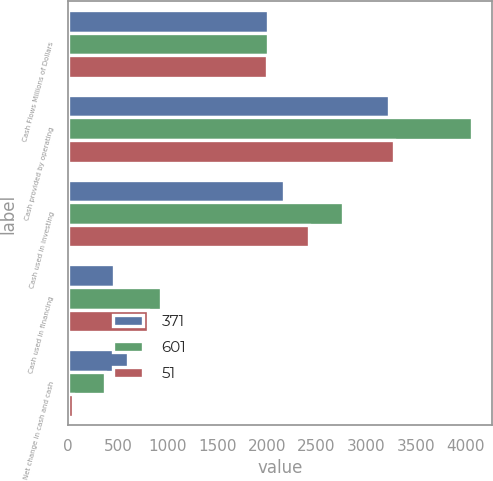<chart> <loc_0><loc_0><loc_500><loc_500><stacked_bar_chart><ecel><fcel>Cash Flows Millions of Dollars<fcel>Cash provided by operating<fcel>Cash used in investing<fcel>Cash used in financing<fcel>Net change in cash and cash<nl><fcel>371<fcel>2009<fcel>3234<fcel>2175<fcel>458<fcel>601<nl><fcel>601<fcel>2008<fcel>4070<fcel>2764<fcel>935<fcel>371<nl><fcel>51<fcel>2007<fcel>3277<fcel>2426<fcel>800<fcel>51<nl></chart> 